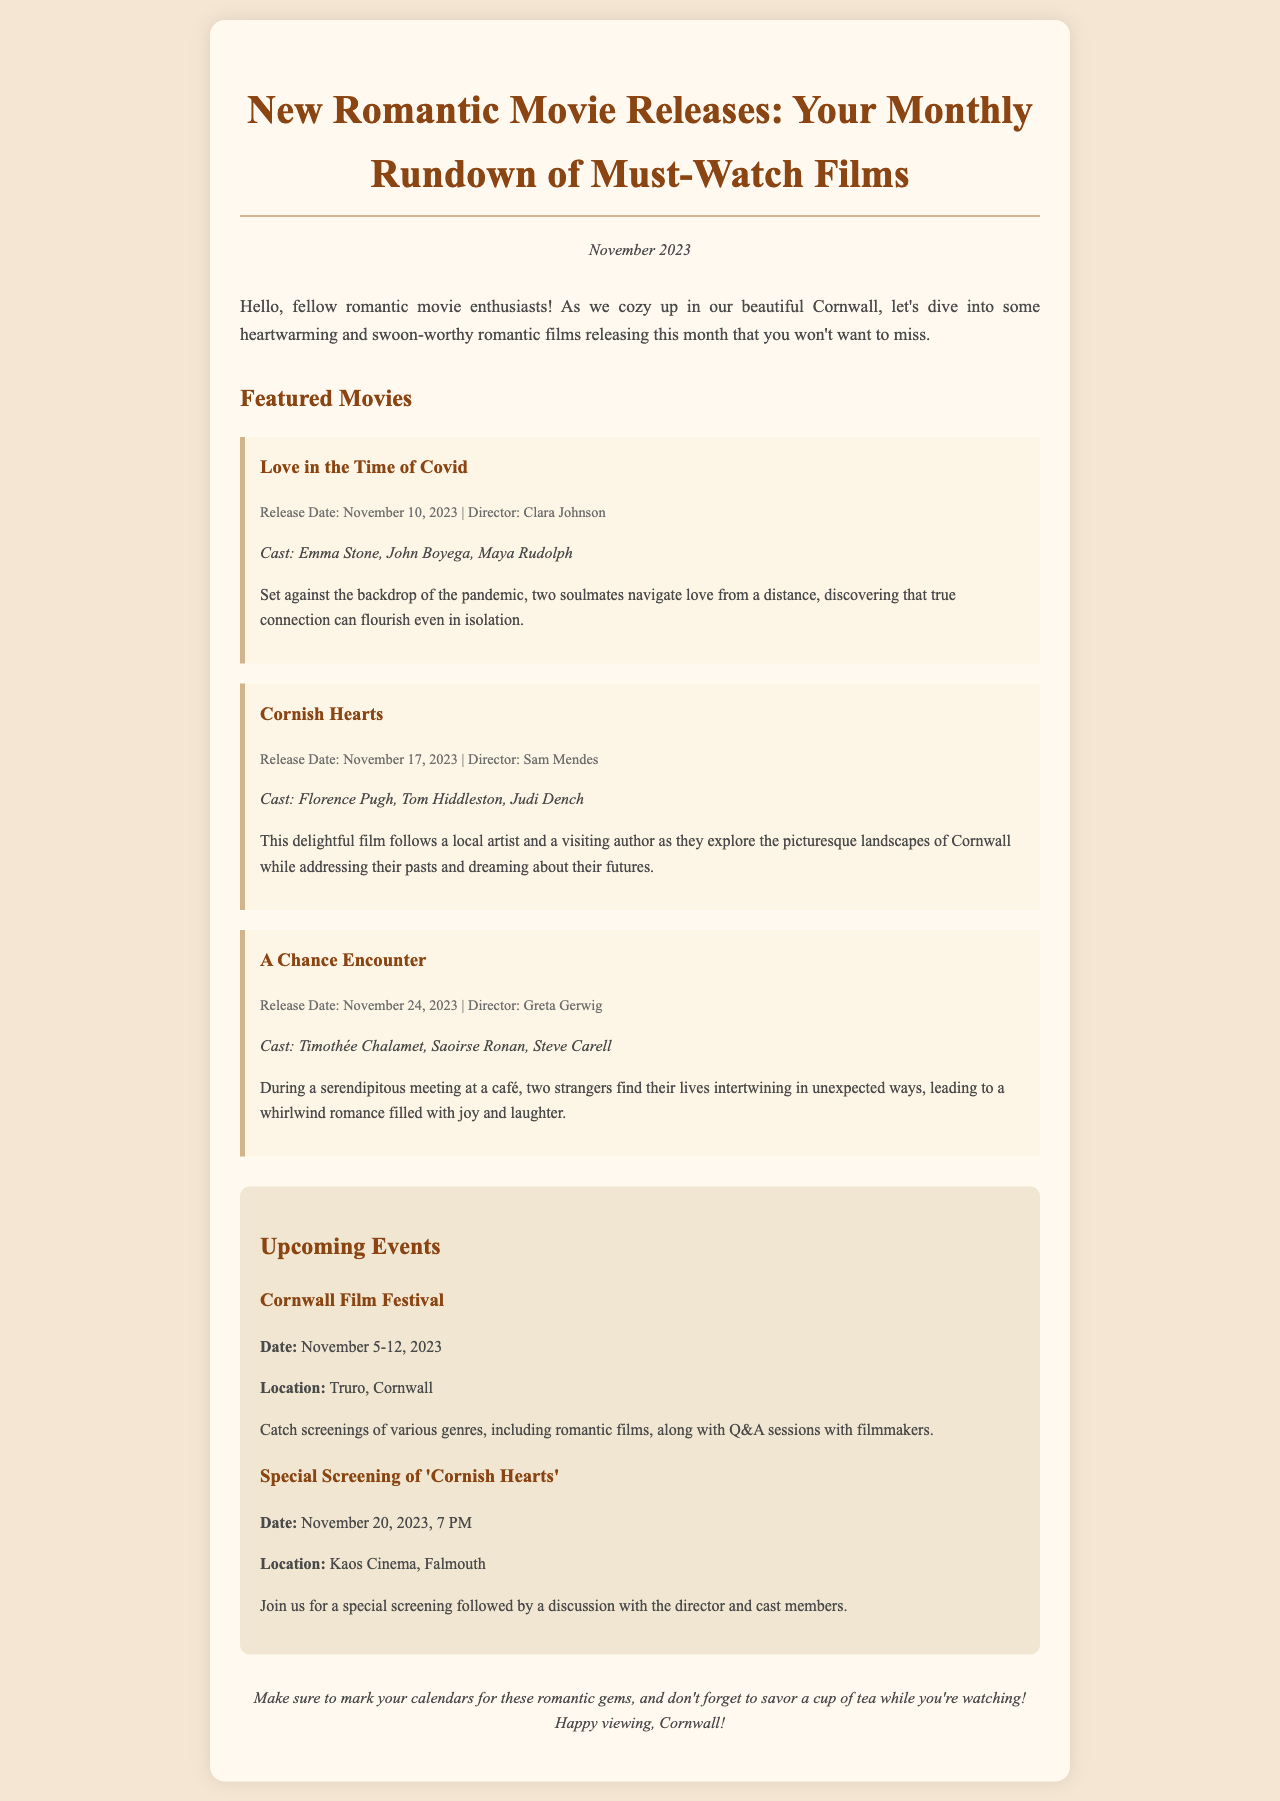What is the release date of "Love in the Time of Covid"? The release date is clearly stated in the movie details section of the document.
Answer: November 10, 2023 Who is the director of "Cornish Hearts"? The director's name is mentioned alongside the movie details in the document's description.
Answer: Sam Mendes Which actress stars in "A Chance Encounter"? The cast list provided includes the names of the actors starring in the film according to the document.
Answer: Saoirse Ronan What is the date of the Cornwall Film Festival? The festival date is provided in the events section of the document, specifying the event's duration.
Answer: November 5-12, 2023 What film features the character of a local artist in Cornwall? The details about the plot and characters clarify which movie showcases this narrative.
Answer: Cornish Hearts How many films are featured in the newsletter? The total count of movies listed is derived from the separate movie sections present in the document.
Answer: Three What is the location of the special screening for "Cornish Hearts"? The location is indicated in the event details within the document.
Answer: Kaos Cinema, Falmouth When is the special screening of "Cornish Hearts"? The date and time for the special screening are explicitly mentioned in the provided event details.
Answer: November 20, 2023, 7 PM What is the main theme of the film "Love in the Time of Covid"? The synopsis provides insight into the film's theme and narrative context as described in the document.
Answer: Navigating love from a distance 